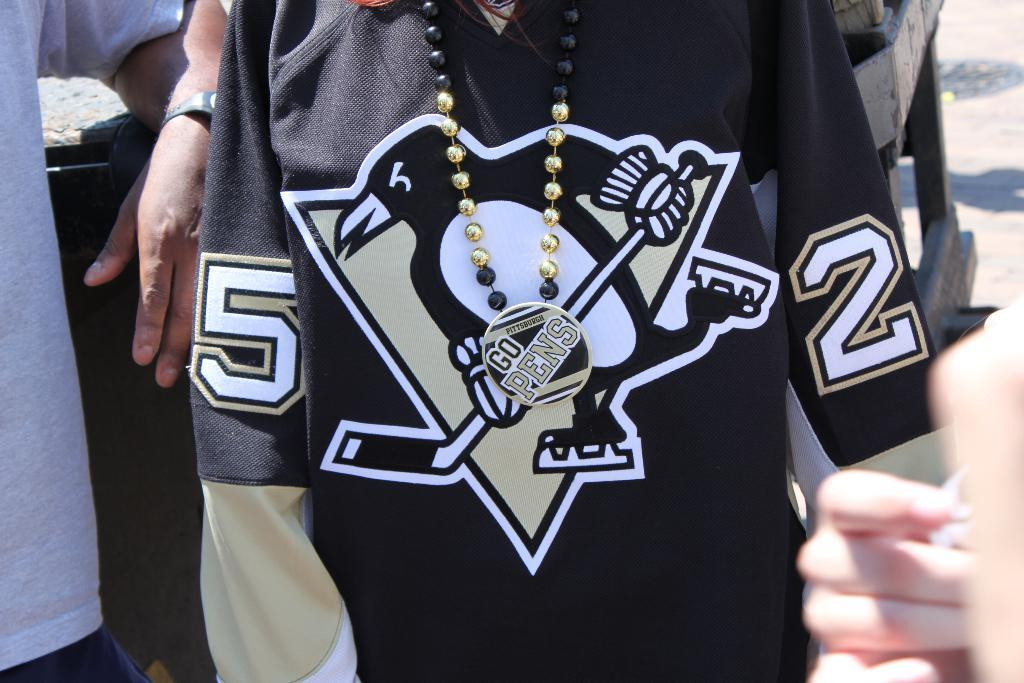<image>
Relay a brief, clear account of the picture shown. A button that reads "Go Pens" is pinned to a black Penguin jersey. 